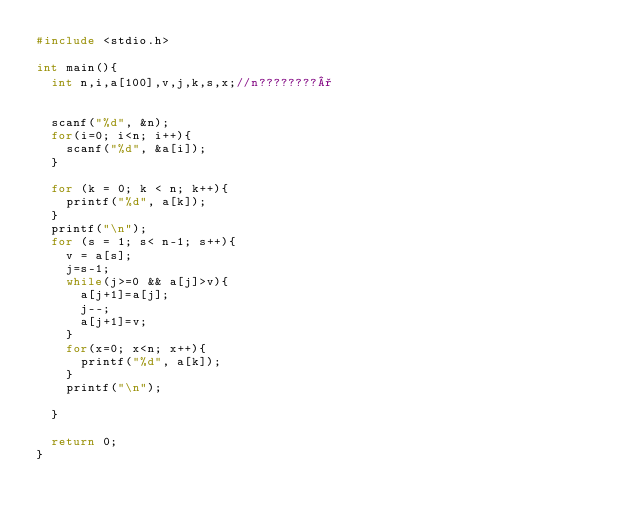Convert code to text. <code><loc_0><loc_0><loc_500><loc_500><_C_>#include <stdio.h>

int main(){
	int n,i,a[100],v,j,k,s,x;//n????????°


	scanf("%d", &n);
	for(i=0; i<n; i++){
		scanf("%d", &a[i]);
	}

	for (k = 0; k < n; k++){
		printf("%d", a[k]);
	}
	printf("\n");
	for (s = 1; s< n-1; s++){
		v = a[s];
		j=s-1;
		while(j>=0 && a[j]>v){
			a[j+1]=a[j];
			j--;
			a[j+1]=v;
		}
		for(x=0; x<n; x++){
			printf("%d", a[k]);
		}
		printf("\n");

	}

	return 0;
}</code> 